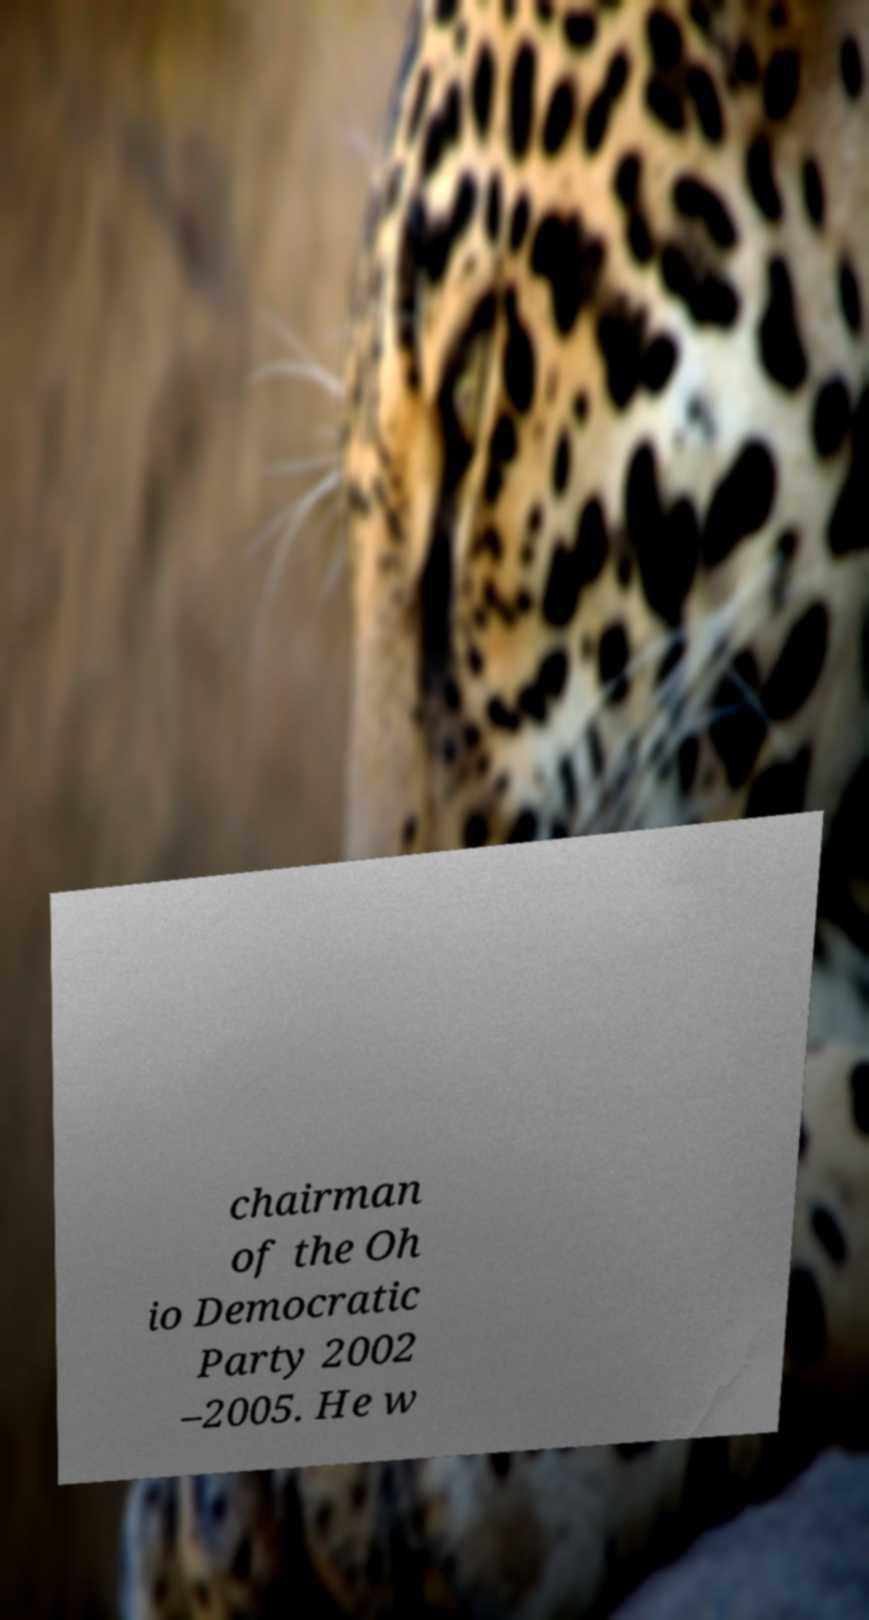What messages or text are displayed in this image? I need them in a readable, typed format. chairman of the Oh io Democratic Party 2002 –2005. He w 